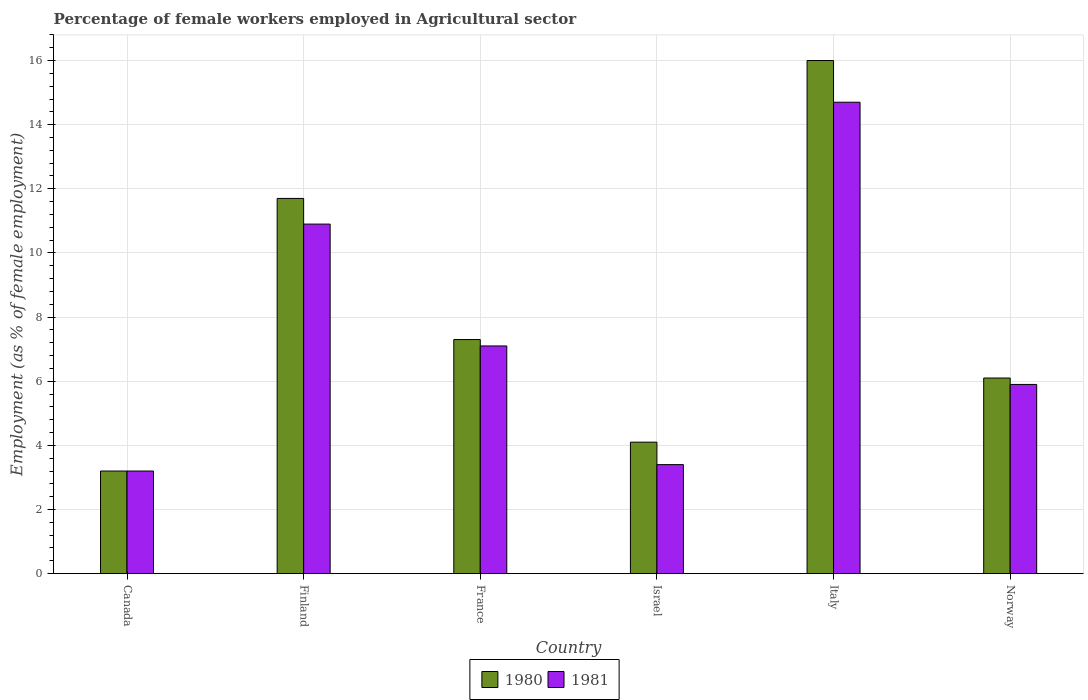How many different coloured bars are there?
Provide a short and direct response. 2. Are the number of bars per tick equal to the number of legend labels?
Provide a short and direct response. Yes. How many bars are there on the 2nd tick from the left?
Provide a short and direct response. 2. How many bars are there on the 2nd tick from the right?
Keep it short and to the point. 2. What is the label of the 6th group of bars from the left?
Offer a terse response. Norway. In how many cases, is the number of bars for a given country not equal to the number of legend labels?
Offer a very short reply. 0. What is the percentage of females employed in Agricultural sector in 1981 in Italy?
Provide a short and direct response. 14.7. Across all countries, what is the minimum percentage of females employed in Agricultural sector in 1980?
Your response must be concise. 3.2. In which country was the percentage of females employed in Agricultural sector in 1980 maximum?
Provide a succinct answer. Italy. What is the total percentage of females employed in Agricultural sector in 1981 in the graph?
Provide a succinct answer. 45.2. What is the difference between the percentage of females employed in Agricultural sector in 1981 in Finland and that in Norway?
Offer a very short reply. 5. What is the difference between the percentage of females employed in Agricultural sector in 1981 in France and the percentage of females employed in Agricultural sector in 1980 in Finland?
Make the answer very short. -4.6. What is the average percentage of females employed in Agricultural sector in 1980 per country?
Offer a terse response. 8.07. What is the difference between the percentage of females employed in Agricultural sector of/in 1981 and percentage of females employed in Agricultural sector of/in 1980 in Norway?
Keep it short and to the point. -0.2. What is the ratio of the percentage of females employed in Agricultural sector in 1981 in Italy to that in Norway?
Your response must be concise. 2.49. Is the percentage of females employed in Agricultural sector in 1981 in Israel less than that in Italy?
Provide a succinct answer. Yes. What is the difference between the highest and the second highest percentage of females employed in Agricultural sector in 1981?
Your response must be concise. -3.8. What is the difference between the highest and the lowest percentage of females employed in Agricultural sector in 1981?
Provide a short and direct response. 11.5. What does the 2nd bar from the left in Italy represents?
Keep it short and to the point. 1981. What does the 2nd bar from the right in Canada represents?
Make the answer very short. 1980. How many countries are there in the graph?
Provide a short and direct response. 6. What is the difference between two consecutive major ticks on the Y-axis?
Offer a very short reply. 2. Does the graph contain any zero values?
Your answer should be very brief. No. Where does the legend appear in the graph?
Make the answer very short. Bottom center. What is the title of the graph?
Make the answer very short. Percentage of female workers employed in Agricultural sector. Does "2013" appear as one of the legend labels in the graph?
Keep it short and to the point. No. What is the label or title of the X-axis?
Keep it short and to the point. Country. What is the label or title of the Y-axis?
Your response must be concise. Employment (as % of female employment). What is the Employment (as % of female employment) of 1980 in Canada?
Give a very brief answer. 3.2. What is the Employment (as % of female employment) in 1981 in Canada?
Provide a short and direct response. 3.2. What is the Employment (as % of female employment) in 1980 in Finland?
Offer a very short reply. 11.7. What is the Employment (as % of female employment) of 1981 in Finland?
Offer a very short reply. 10.9. What is the Employment (as % of female employment) in 1980 in France?
Make the answer very short. 7.3. What is the Employment (as % of female employment) in 1981 in France?
Provide a succinct answer. 7.1. What is the Employment (as % of female employment) in 1980 in Israel?
Give a very brief answer. 4.1. What is the Employment (as % of female employment) of 1981 in Israel?
Keep it short and to the point. 3.4. What is the Employment (as % of female employment) in 1980 in Italy?
Your response must be concise. 16. What is the Employment (as % of female employment) in 1981 in Italy?
Your answer should be very brief. 14.7. What is the Employment (as % of female employment) in 1980 in Norway?
Your answer should be compact. 6.1. What is the Employment (as % of female employment) in 1981 in Norway?
Your answer should be very brief. 5.9. Across all countries, what is the maximum Employment (as % of female employment) in 1981?
Provide a succinct answer. 14.7. Across all countries, what is the minimum Employment (as % of female employment) of 1980?
Give a very brief answer. 3.2. Across all countries, what is the minimum Employment (as % of female employment) of 1981?
Keep it short and to the point. 3.2. What is the total Employment (as % of female employment) of 1980 in the graph?
Provide a succinct answer. 48.4. What is the total Employment (as % of female employment) in 1981 in the graph?
Provide a succinct answer. 45.2. What is the difference between the Employment (as % of female employment) of 1980 in Canada and that in Finland?
Provide a short and direct response. -8.5. What is the difference between the Employment (as % of female employment) of 1980 in Canada and that in France?
Offer a terse response. -4.1. What is the difference between the Employment (as % of female employment) of 1980 in Canada and that in Israel?
Make the answer very short. -0.9. What is the difference between the Employment (as % of female employment) in 1981 in Canada and that in Israel?
Provide a short and direct response. -0.2. What is the difference between the Employment (as % of female employment) in 1980 in Canada and that in Italy?
Make the answer very short. -12.8. What is the difference between the Employment (as % of female employment) in 1980 in Finland and that in Israel?
Make the answer very short. 7.6. What is the difference between the Employment (as % of female employment) of 1980 in Finland and that in Norway?
Keep it short and to the point. 5.6. What is the difference between the Employment (as % of female employment) in 1981 in France and that in Israel?
Give a very brief answer. 3.7. What is the difference between the Employment (as % of female employment) in 1980 in France and that in Italy?
Offer a terse response. -8.7. What is the difference between the Employment (as % of female employment) of 1980 in Israel and that in Norway?
Ensure brevity in your answer.  -2. What is the difference between the Employment (as % of female employment) in 1981 in Israel and that in Norway?
Your answer should be compact. -2.5. What is the difference between the Employment (as % of female employment) of 1980 in Italy and that in Norway?
Make the answer very short. 9.9. What is the difference between the Employment (as % of female employment) in 1980 in Canada and the Employment (as % of female employment) in 1981 in Italy?
Provide a short and direct response. -11.5. What is the difference between the Employment (as % of female employment) of 1980 in Canada and the Employment (as % of female employment) of 1981 in Norway?
Your answer should be very brief. -2.7. What is the difference between the Employment (as % of female employment) of 1980 in Finland and the Employment (as % of female employment) of 1981 in France?
Ensure brevity in your answer.  4.6. What is the difference between the Employment (as % of female employment) in 1980 in Finland and the Employment (as % of female employment) in 1981 in Israel?
Your answer should be very brief. 8.3. What is the difference between the Employment (as % of female employment) of 1980 in Finland and the Employment (as % of female employment) of 1981 in Italy?
Keep it short and to the point. -3. What is the difference between the Employment (as % of female employment) in 1980 in France and the Employment (as % of female employment) in 1981 in Norway?
Your response must be concise. 1.4. What is the difference between the Employment (as % of female employment) of 1980 in Israel and the Employment (as % of female employment) of 1981 in Norway?
Offer a terse response. -1.8. What is the difference between the Employment (as % of female employment) in 1980 in Italy and the Employment (as % of female employment) in 1981 in Norway?
Provide a succinct answer. 10.1. What is the average Employment (as % of female employment) in 1980 per country?
Your answer should be very brief. 8.07. What is the average Employment (as % of female employment) in 1981 per country?
Your answer should be compact. 7.53. What is the difference between the Employment (as % of female employment) in 1980 and Employment (as % of female employment) in 1981 in Finland?
Ensure brevity in your answer.  0.8. What is the difference between the Employment (as % of female employment) in 1980 and Employment (as % of female employment) in 1981 in Israel?
Offer a very short reply. 0.7. What is the difference between the Employment (as % of female employment) in 1980 and Employment (as % of female employment) in 1981 in Italy?
Your answer should be compact. 1.3. What is the difference between the Employment (as % of female employment) in 1980 and Employment (as % of female employment) in 1981 in Norway?
Your answer should be compact. 0.2. What is the ratio of the Employment (as % of female employment) in 1980 in Canada to that in Finland?
Give a very brief answer. 0.27. What is the ratio of the Employment (as % of female employment) in 1981 in Canada to that in Finland?
Provide a succinct answer. 0.29. What is the ratio of the Employment (as % of female employment) of 1980 in Canada to that in France?
Provide a succinct answer. 0.44. What is the ratio of the Employment (as % of female employment) in 1981 in Canada to that in France?
Provide a short and direct response. 0.45. What is the ratio of the Employment (as % of female employment) in 1980 in Canada to that in Israel?
Keep it short and to the point. 0.78. What is the ratio of the Employment (as % of female employment) in 1981 in Canada to that in Israel?
Provide a short and direct response. 0.94. What is the ratio of the Employment (as % of female employment) of 1980 in Canada to that in Italy?
Ensure brevity in your answer.  0.2. What is the ratio of the Employment (as % of female employment) of 1981 in Canada to that in Italy?
Offer a very short reply. 0.22. What is the ratio of the Employment (as % of female employment) of 1980 in Canada to that in Norway?
Offer a terse response. 0.52. What is the ratio of the Employment (as % of female employment) of 1981 in Canada to that in Norway?
Offer a very short reply. 0.54. What is the ratio of the Employment (as % of female employment) in 1980 in Finland to that in France?
Your answer should be compact. 1.6. What is the ratio of the Employment (as % of female employment) in 1981 in Finland to that in France?
Offer a very short reply. 1.54. What is the ratio of the Employment (as % of female employment) of 1980 in Finland to that in Israel?
Provide a short and direct response. 2.85. What is the ratio of the Employment (as % of female employment) in 1981 in Finland to that in Israel?
Offer a very short reply. 3.21. What is the ratio of the Employment (as % of female employment) of 1980 in Finland to that in Italy?
Your response must be concise. 0.73. What is the ratio of the Employment (as % of female employment) of 1981 in Finland to that in Italy?
Make the answer very short. 0.74. What is the ratio of the Employment (as % of female employment) of 1980 in Finland to that in Norway?
Offer a terse response. 1.92. What is the ratio of the Employment (as % of female employment) in 1981 in Finland to that in Norway?
Your answer should be very brief. 1.85. What is the ratio of the Employment (as % of female employment) in 1980 in France to that in Israel?
Make the answer very short. 1.78. What is the ratio of the Employment (as % of female employment) of 1981 in France to that in Israel?
Your answer should be compact. 2.09. What is the ratio of the Employment (as % of female employment) in 1980 in France to that in Italy?
Offer a terse response. 0.46. What is the ratio of the Employment (as % of female employment) in 1981 in France to that in Italy?
Your answer should be very brief. 0.48. What is the ratio of the Employment (as % of female employment) in 1980 in France to that in Norway?
Ensure brevity in your answer.  1.2. What is the ratio of the Employment (as % of female employment) in 1981 in France to that in Norway?
Your response must be concise. 1.2. What is the ratio of the Employment (as % of female employment) of 1980 in Israel to that in Italy?
Make the answer very short. 0.26. What is the ratio of the Employment (as % of female employment) of 1981 in Israel to that in Italy?
Keep it short and to the point. 0.23. What is the ratio of the Employment (as % of female employment) of 1980 in Israel to that in Norway?
Offer a very short reply. 0.67. What is the ratio of the Employment (as % of female employment) of 1981 in Israel to that in Norway?
Your answer should be very brief. 0.58. What is the ratio of the Employment (as % of female employment) of 1980 in Italy to that in Norway?
Your answer should be very brief. 2.62. What is the ratio of the Employment (as % of female employment) in 1981 in Italy to that in Norway?
Give a very brief answer. 2.49. What is the difference between the highest and the second highest Employment (as % of female employment) in 1981?
Your answer should be very brief. 3.8. What is the difference between the highest and the lowest Employment (as % of female employment) in 1980?
Your answer should be very brief. 12.8. 